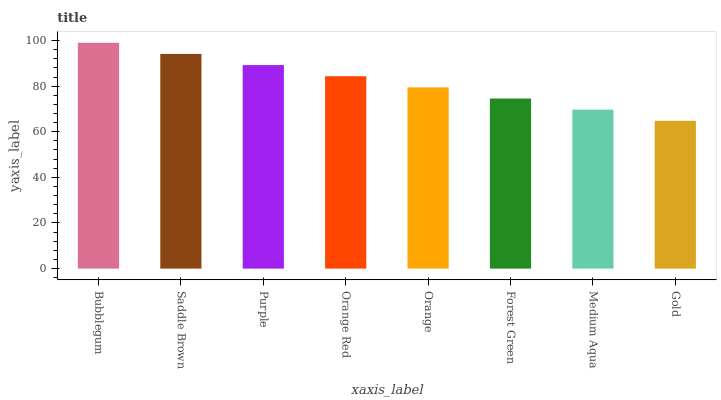Is Gold the minimum?
Answer yes or no. Yes. Is Bubblegum the maximum?
Answer yes or no. Yes. Is Saddle Brown the minimum?
Answer yes or no. No. Is Saddle Brown the maximum?
Answer yes or no. No. Is Bubblegum greater than Saddle Brown?
Answer yes or no. Yes. Is Saddle Brown less than Bubblegum?
Answer yes or no. Yes. Is Saddle Brown greater than Bubblegum?
Answer yes or no. No. Is Bubblegum less than Saddle Brown?
Answer yes or no. No. Is Orange Red the high median?
Answer yes or no. Yes. Is Orange the low median?
Answer yes or no. Yes. Is Gold the high median?
Answer yes or no. No. Is Gold the low median?
Answer yes or no. No. 